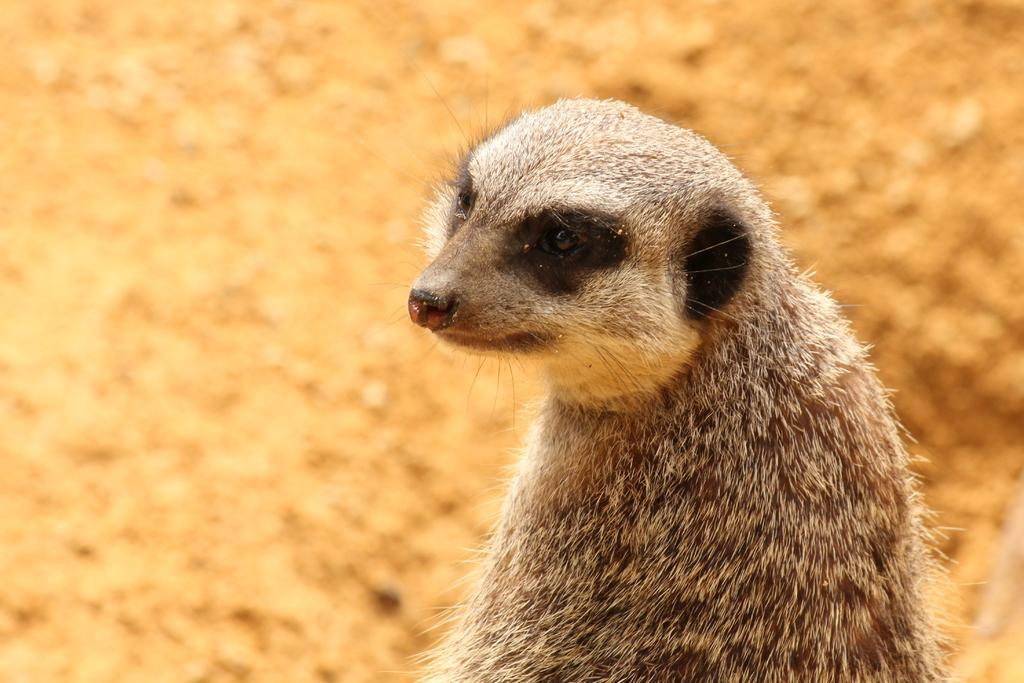What animal is the main subject of the image? There is a meerkat in the image. Can you describe the background of the image? The background of the image is blurred. How many pins are used to hold the meerkat's tail in the image? There are no pins present in the image, and the meerkat's tail is not being held by any object. What mathematical operation is being performed by the meerkat in the image? There is no indication of any mathematical operation being performed in the image; the meerkat is simply the main subject. 